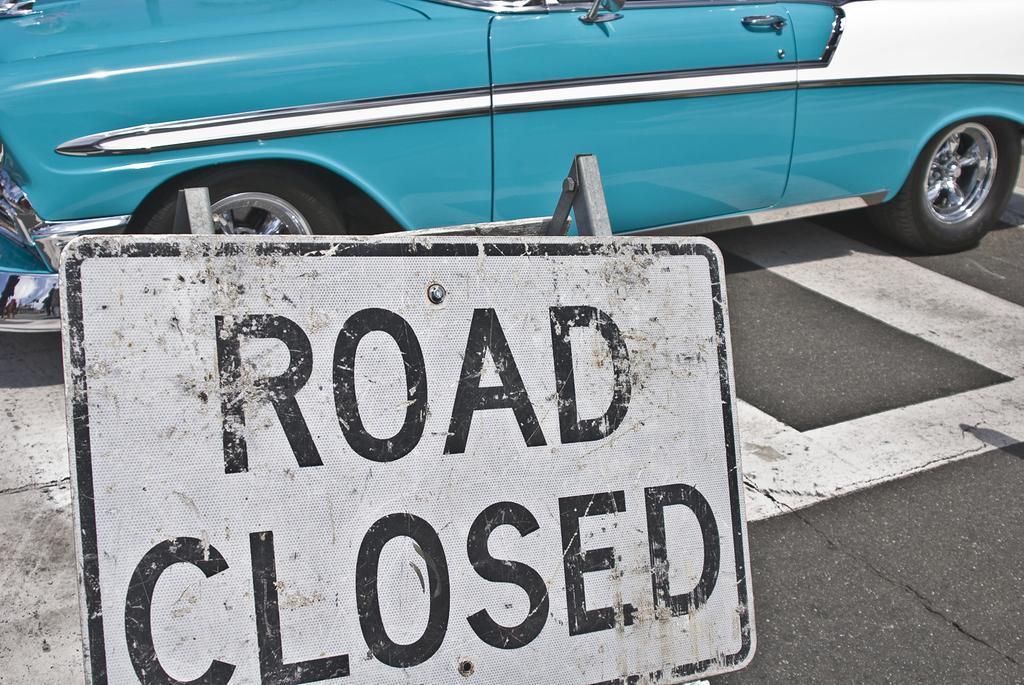Describe this image in one or two sentences. In this picture we can see a vehicle on the road. There are a few white lines on this road. We can see a reflection on the right side. 